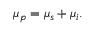<formula> <loc_0><loc_0><loc_500><loc_500>\begin{array} { r } { \mu _ { p } = \mu _ { s } + \mu _ { i } . } \end{array}</formula> 